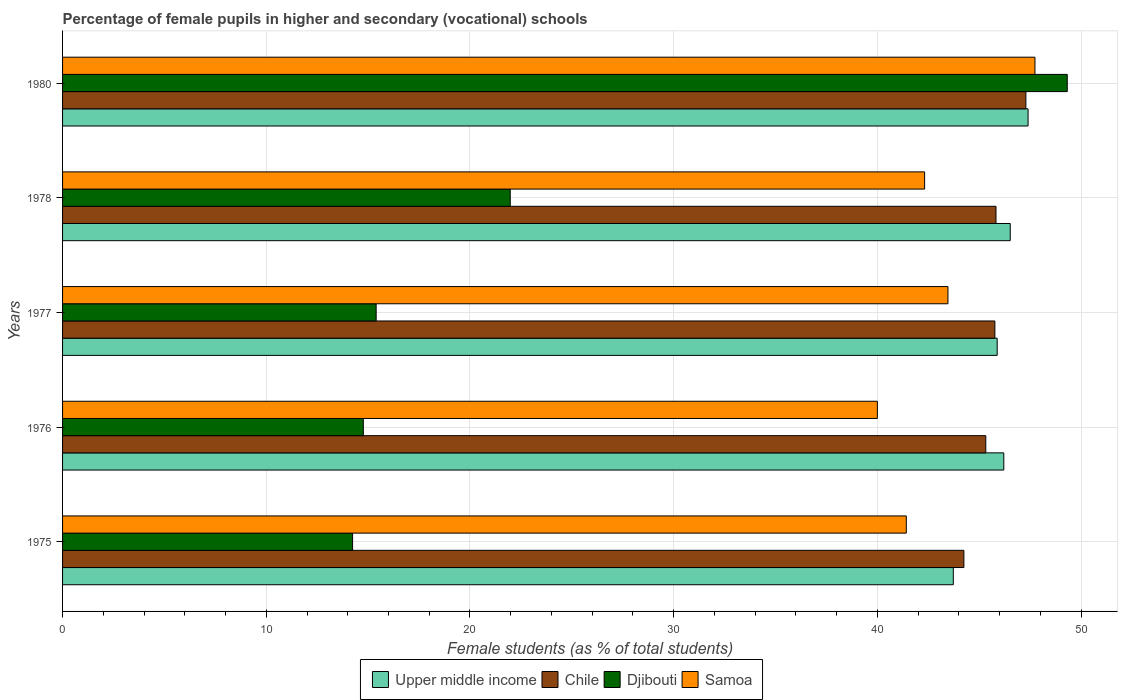How many bars are there on the 5th tick from the top?
Your answer should be very brief. 4. What is the label of the 1st group of bars from the top?
Provide a short and direct response. 1980. In how many cases, is the number of bars for a given year not equal to the number of legend labels?
Provide a succinct answer. 0. What is the percentage of female pupils in higher and secondary schools in Upper middle income in 1977?
Give a very brief answer. 45.88. Across all years, what is the maximum percentage of female pupils in higher and secondary schools in Upper middle income?
Make the answer very short. 47.4. Across all years, what is the minimum percentage of female pupils in higher and secondary schools in Samoa?
Make the answer very short. 40. In which year was the percentage of female pupils in higher and secondary schools in Samoa maximum?
Keep it short and to the point. 1980. In which year was the percentage of female pupils in higher and secondary schools in Upper middle income minimum?
Your answer should be compact. 1975. What is the total percentage of female pupils in higher and secondary schools in Upper middle income in the graph?
Keep it short and to the point. 229.74. What is the difference between the percentage of female pupils in higher and secondary schools in Upper middle income in 1976 and that in 1978?
Make the answer very short. -0.32. What is the difference between the percentage of female pupils in higher and secondary schools in Djibouti in 1980 and the percentage of female pupils in higher and secondary schools in Samoa in 1976?
Your answer should be very brief. 9.32. What is the average percentage of female pupils in higher and secondary schools in Samoa per year?
Your answer should be compact. 42.99. In the year 1980, what is the difference between the percentage of female pupils in higher and secondary schools in Samoa and percentage of female pupils in higher and secondary schools in Chile?
Provide a succinct answer. 0.45. What is the ratio of the percentage of female pupils in higher and secondary schools in Upper middle income in 1977 to that in 1978?
Your answer should be compact. 0.99. Is the difference between the percentage of female pupils in higher and secondary schools in Samoa in 1977 and 1978 greater than the difference between the percentage of female pupils in higher and secondary schools in Chile in 1977 and 1978?
Provide a short and direct response. Yes. What is the difference between the highest and the second highest percentage of female pupils in higher and secondary schools in Djibouti?
Provide a succinct answer. 27.35. What is the difference between the highest and the lowest percentage of female pupils in higher and secondary schools in Upper middle income?
Your answer should be very brief. 3.67. In how many years, is the percentage of female pupils in higher and secondary schools in Samoa greater than the average percentage of female pupils in higher and secondary schools in Samoa taken over all years?
Provide a short and direct response. 2. Is the sum of the percentage of female pupils in higher and secondary schools in Upper middle income in 1975 and 1976 greater than the maximum percentage of female pupils in higher and secondary schools in Samoa across all years?
Offer a terse response. Yes. What does the 4th bar from the top in 1975 represents?
Your answer should be compact. Upper middle income. What does the 1st bar from the bottom in 1978 represents?
Provide a short and direct response. Upper middle income. Is it the case that in every year, the sum of the percentage of female pupils in higher and secondary schools in Samoa and percentage of female pupils in higher and secondary schools in Upper middle income is greater than the percentage of female pupils in higher and secondary schools in Chile?
Provide a succinct answer. Yes. Are all the bars in the graph horizontal?
Ensure brevity in your answer.  Yes. How many years are there in the graph?
Provide a short and direct response. 5. What is the difference between two consecutive major ticks on the X-axis?
Offer a terse response. 10. Are the values on the major ticks of X-axis written in scientific E-notation?
Provide a succinct answer. No. How many legend labels are there?
Ensure brevity in your answer.  4. What is the title of the graph?
Keep it short and to the point. Percentage of female pupils in higher and secondary (vocational) schools. Does "St. Kitts and Nevis" appear as one of the legend labels in the graph?
Your response must be concise. No. What is the label or title of the X-axis?
Offer a terse response. Female students (as % of total students). What is the label or title of the Y-axis?
Offer a terse response. Years. What is the Female students (as % of total students) in Upper middle income in 1975?
Your answer should be compact. 43.73. What is the Female students (as % of total students) of Chile in 1975?
Your answer should be very brief. 44.25. What is the Female students (as % of total students) in Djibouti in 1975?
Offer a terse response. 14.24. What is the Female students (as % of total students) of Samoa in 1975?
Keep it short and to the point. 41.42. What is the Female students (as % of total students) of Upper middle income in 1976?
Offer a terse response. 46.21. What is the Female students (as % of total students) of Chile in 1976?
Your response must be concise. 45.32. What is the Female students (as % of total students) of Djibouti in 1976?
Make the answer very short. 14.77. What is the Female students (as % of total students) in Upper middle income in 1977?
Your answer should be very brief. 45.88. What is the Female students (as % of total students) in Chile in 1977?
Provide a short and direct response. 45.77. What is the Female students (as % of total students) of Djibouti in 1977?
Provide a short and direct response. 15.4. What is the Female students (as % of total students) of Samoa in 1977?
Your answer should be compact. 43.47. What is the Female students (as % of total students) of Upper middle income in 1978?
Provide a short and direct response. 46.52. What is the Female students (as % of total students) in Chile in 1978?
Make the answer very short. 45.82. What is the Female students (as % of total students) of Djibouti in 1978?
Provide a succinct answer. 21.98. What is the Female students (as % of total students) in Samoa in 1978?
Offer a terse response. 42.32. What is the Female students (as % of total students) of Upper middle income in 1980?
Keep it short and to the point. 47.4. What is the Female students (as % of total students) in Chile in 1980?
Keep it short and to the point. 47.29. What is the Female students (as % of total students) in Djibouti in 1980?
Provide a succinct answer. 49.32. What is the Female students (as % of total students) in Samoa in 1980?
Make the answer very short. 47.74. Across all years, what is the maximum Female students (as % of total students) in Upper middle income?
Provide a succinct answer. 47.4. Across all years, what is the maximum Female students (as % of total students) in Chile?
Your answer should be very brief. 47.29. Across all years, what is the maximum Female students (as % of total students) in Djibouti?
Your response must be concise. 49.32. Across all years, what is the maximum Female students (as % of total students) in Samoa?
Ensure brevity in your answer.  47.74. Across all years, what is the minimum Female students (as % of total students) in Upper middle income?
Ensure brevity in your answer.  43.73. Across all years, what is the minimum Female students (as % of total students) in Chile?
Give a very brief answer. 44.25. Across all years, what is the minimum Female students (as % of total students) in Djibouti?
Offer a very short reply. 14.24. What is the total Female students (as % of total students) of Upper middle income in the graph?
Offer a terse response. 229.74. What is the total Female students (as % of total students) in Chile in the graph?
Provide a short and direct response. 228.45. What is the total Female students (as % of total students) of Djibouti in the graph?
Your answer should be compact. 115.7. What is the total Female students (as % of total students) of Samoa in the graph?
Provide a succinct answer. 214.94. What is the difference between the Female students (as % of total students) of Upper middle income in 1975 and that in 1976?
Your response must be concise. -2.48. What is the difference between the Female students (as % of total students) of Chile in 1975 and that in 1976?
Your answer should be compact. -1.08. What is the difference between the Female students (as % of total students) in Djibouti in 1975 and that in 1976?
Your response must be concise. -0.53. What is the difference between the Female students (as % of total students) of Samoa in 1975 and that in 1976?
Provide a succinct answer. 1.42. What is the difference between the Female students (as % of total students) in Upper middle income in 1975 and that in 1977?
Provide a succinct answer. -2.15. What is the difference between the Female students (as % of total students) of Chile in 1975 and that in 1977?
Ensure brevity in your answer.  -1.52. What is the difference between the Female students (as % of total students) of Djibouti in 1975 and that in 1977?
Your answer should be very brief. -1.16. What is the difference between the Female students (as % of total students) in Samoa in 1975 and that in 1977?
Make the answer very short. -2.04. What is the difference between the Female students (as % of total students) in Upper middle income in 1975 and that in 1978?
Make the answer very short. -2.8. What is the difference between the Female students (as % of total students) of Chile in 1975 and that in 1978?
Offer a very short reply. -1.58. What is the difference between the Female students (as % of total students) of Djibouti in 1975 and that in 1978?
Offer a very short reply. -7.74. What is the difference between the Female students (as % of total students) in Samoa in 1975 and that in 1978?
Give a very brief answer. -0.9. What is the difference between the Female students (as % of total students) in Upper middle income in 1975 and that in 1980?
Your answer should be very brief. -3.67. What is the difference between the Female students (as % of total students) in Chile in 1975 and that in 1980?
Your answer should be compact. -3.04. What is the difference between the Female students (as % of total students) of Djibouti in 1975 and that in 1980?
Your response must be concise. -35.08. What is the difference between the Female students (as % of total students) of Samoa in 1975 and that in 1980?
Your answer should be very brief. -6.32. What is the difference between the Female students (as % of total students) of Upper middle income in 1976 and that in 1977?
Provide a short and direct response. 0.33. What is the difference between the Female students (as % of total students) of Chile in 1976 and that in 1977?
Your answer should be very brief. -0.45. What is the difference between the Female students (as % of total students) in Djibouti in 1976 and that in 1977?
Provide a succinct answer. -0.63. What is the difference between the Female students (as % of total students) in Samoa in 1976 and that in 1977?
Provide a short and direct response. -3.46. What is the difference between the Female students (as % of total students) in Upper middle income in 1976 and that in 1978?
Give a very brief answer. -0.32. What is the difference between the Female students (as % of total students) in Chile in 1976 and that in 1978?
Give a very brief answer. -0.5. What is the difference between the Female students (as % of total students) of Djibouti in 1976 and that in 1978?
Provide a succinct answer. -7.21. What is the difference between the Female students (as % of total students) of Samoa in 1976 and that in 1978?
Ensure brevity in your answer.  -2.32. What is the difference between the Female students (as % of total students) in Upper middle income in 1976 and that in 1980?
Your answer should be compact. -1.19. What is the difference between the Female students (as % of total students) of Chile in 1976 and that in 1980?
Ensure brevity in your answer.  -1.97. What is the difference between the Female students (as % of total students) in Djibouti in 1976 and that in 1980?
Provide a succinct answer. -34.56. What is the difference between the Female students (as % of total students) in Samoa in 1976 and that in 1980?
Your response must be concise. -7.74. What is the difference between the Female students (as % of total students) in Upper middle income in 1977 and that in 1978?
Offer a very short reply. -0.64. What is the difference between the Female students (as % of total students) of Chile in 1977 and that in 1978?
Offer a very short reply. -0.05. What is the difference between the Female students (as % of total students) of Djibouti in 1977 and that in 1978?
Offer a terse response. -6.58. What is the difference between the Female students (as % of total students) in Samoa in 1977 and that in 1978?
Ensure brevity in your answer.  1.15. What is the difference between the Female students (as % of total students) in Upper middle income in 1977 and that in 1980?
Your answer should be very brief. -1.52. What is the difference between the Female students (as % of total students) in Chile in 1977 and that in 1980?
Provide a short and direct response. -1.52. What is the difference between the Female students (as % of total students) of Djibouti in 1977 and that in 1980?
Your response must be concise. -33.93. What is the difference between the Female students (as % of total students) of Samoa in 1977 and that in 1980?
Ensure brevity in your answer.  -4.27. What is the difference between the Female students (as % of total students) of Upper middle income in 1978 and that in 1980?
Your answer should be very brief. -0.87. What is the difference between the Female students (as % of total students) of Chile in 1978 and that in 1980?
Keep it short and to the point. -1.47. What is the difference between the Female students (as % of total students) in Djibouti in 1978 and that in 1980?
Offer a very short reply. -27.35. What is the difference between the Female students (as % of total students) in Samoa in 1978 and that in 1980?
Provide a succinct answer. -5.42. What is the difference between the Female students (as % of total students) in Upper middle income in 1975 and the Female students (as % of total students) in Chile in 1976?
Give a very brief answer. -1.59. What is the difference between the Female students (as % of total students) in Upper middle income in 1975 and the Female students (as % of total students) in Djibouti in 1976?
Make the answer very short. 28.96. What is the difference between the Female students (as % of total students) in Upper middle income in 1975 and the Female students (as % of total students) in Samoa in 1976?
Provide a short and direct response. 3.73. What is the difference between the Female students (as % of total students) in Chile in 1975 and the Female students (as % of total students) in Djibouti in 1976?
Your response must be concise. 29.48. What is the difference between the Female students (as % of total students) of Chile in 1975 and the Female students (as % of total students) of Samoa in 1976?
Offer a terse response. 4.25. What is the difference between the Female students (as % of total students) in Djibouti in 1975 and the Female students (as % of total students) in Samoa in 1976?
Provide a short and direct response. -25.76. What is the difference between the Female students (as % of total students) in Upper middle income in 1975 and the Female students (as % of total students) in Chile in 1977?
Ensure brevity in your answer.  -2.04. What is the difference between the Female students (as % of total students) in Upper middle income in 1975 and the Female students (as % of total students) in Djibouti in 1977?
Provide a succinct answer. 28.33. What is the difference between the Female students (as % of total students) in Upper middle income in 1975 and the Female students (as % of total students) in Samoa in 1977?
Your answer should be compact. 0.26. What is the difference between the Female students (as % of total students) in Chile in 1975 and the Female students (as % of total students) in Djibouti in 1977?
Make the answer very short. 28.85. What is the difference between the Female students (as % of total students) in Chile in 1975 and the Female students (as % of total students) in Samoa in 1977?
Your answer should be compact. 0.78. What is the difference between the Female students (as % of total students) of Djibouti in 1975 and the Female students (as % of total students) of Samoa in 1977?
Offer a very short reply. -29.23. What is the difference between the Female students (as % of total students) of Upper middle income in 1975 and the Female students (as % of total students) of Chile in 1978?
Give a very brief answer. -2.1. What is the difference between the Female students (as % of total students) in Upper middle income in 1975 and the Female students (as % of total students) in Djibouti in 1978?
Offer a terse response. 21.75. What is the difference between the Female students (as % of total students) of Upper middle income in 1975 and the Female students (as % of total students) of Samoa in 1978?
Make the answer very short. 1.41. What is the difference between the Female students (as % of total students) in Chile in 1975 and the Female students (as % of total students) in Djibouti in 1978?
Your answer should be very brief. 22.27. What is the difference between the Female students (as % of total students) of Chile in 1975 and the Female students (as % of total students) of Samoa in 1978?
Make the answer very short. 1.93. What is the difference between the Female students (as % of total students) in Djibouti in 1975 and the Female students (as % of total students) in Samoa in 1978?
Provide a short and direct response. -28.08. What is the difference between the Female students (as % of total students) of Upper middle income in 1975 and the Female students (as % of total students) of Chile in 1980?
Your answer should be very brief. -3.56. What is the difference between the Female students (as % of total students) of Upper middle income in 1975 and the Female students (as % of total students) of Djibouti in 1980?
Ensure brevity in your answer.  -5.59. What is the difference between the Female students (as % of total students) of Upper middle income in 1975 and the Female students (as % of total students) of Samoa in 1980?
Make the answer very short. -4.01. What is the difference between the Female students (as % of total students) of Chile in 1975 and the Female students (as % of total students) of Djibouti in 1980?
Give a very brief answer. -5.07. What is the difference between the Female students (as % of total students) in Chile in 1975 and the Female students (as % of total students) in Samoa in 1980?
Provide a succinct answer. -3.49. What is the difference between the Female students (as % of total students) of Djibouti in 1975 and the Female students (as % of total students) of Samoa in 1980?
Make the answer very short. -33.5. What is the difference between the Female students (as % of total students) in Upper middle income in 1976 and the Female students (as % of total students) in Chile in 1977?
Your answer should be compact. 0.44. What is the difference between the Female students (as % of total students) of Upper middle income in 1976 and the Female students (as % of total students) of Djibouti in 1977?
Your answer should be very brief. 30.81. What is the difference between the Female students (as % of total students) of Upper middle income in 1976 and the Female students (as % of total students) of Samoa in 1977?
Provide a succinct answer. 2.74. What is the difference between the Female students (as % of total students) of Chile in 1976 and the Female students (as % of total students) of Djibouti in 1977?
Your answer should be compact. 29.93. What is the difference between the Female students (as % of total students) in Chile in 1976 and the Female students (as % of total students) in Samoa in 1977?
Ensure brevity in your answer.  1.86. What is the difference between the Female students (as % of total students) in Djibouti in 1976 and the Female students (as % of total students) in Samoa in 1977?
Your answer should be compact. -28.7. What is the difference between the Female students (as % of total students) of Upper middle income in 1976 and the Female students (as % of total students) of Chile in 1978?
Your answer should be very brief. 0.38. What is the difference between the Female students (as % of total students) of Upper middle income in 1976 and the Female students (as % of total students) of Djibouti in 1978?
Provide a succinct answer. 24.23. What is the difference between the Female students (as % of total students) in Upper middle income in 1976 and the Female students (as % of total students) in Samoa in 1978?
Your answer should be very brief. 3.89. What is the difference between the Female students (as % of total students) of Chile in 1976 and the Female students (as % of total students) of Djibouti in 1978?
Your answer should be compact. 23.35. What is the difference between the Female students (as % of total students) in Chile in 1976 and the Female students (as % of total students) in Samoa in 1978?
Provide a short and direct response. 3. What is the difference between the Female students (as % of total students) of Djibouti in 1976 and the Female students (as % of total students) of Samoa in 1978?
Your response must be concise. -27.55. What is the difference between the Female students (as % of total students) of Upper middle income in 1976 and the Female students (as % of total students) of Chile in 1980?
Give a very brief answer. -1.08. What is the difference between the Female students (as % of total students) in Upper middle income in 1976 and the Female students (as % of total students) in Djibouti in 1980?
Provide a succinct answer. -3.11. What is the difference between the Female students (as % of total students) of Upper middle income in 1976 and the Female students (as % of total students) of Samoa in 1980?
Keep it short and to the point. -1.53. What is the difference between the Female students (as % of total students) of Chile in 1976 and the Female students (as % of total students) of Djibouti in 1980?
Make the answer very short. -4. What is the difference between the Female students (as % of total students) in Chile in 1976 and the Female students (as % of total students) in Samoa in 1980?
Offer a very short reply. -2.41. What is the difference between the Female students (as % of total students) in Djibouti in 1976 and the Female students (as % of total students) in Samoa in 1980?
Keep it short and to the point. -32.97. What is the difference between the Female students (as % of total students) of Upper middle income in 1977 and the Female students (as % of total students) of Chile in 1978?
Offer a terse response. 0.06. What is the difference between the Female students (as % of total students) of Upper middle income in 1977 and the Female students (as % of total students) of Djibouti in 1978?
Make the answer very short. 23.91. What is the difference between the Female students (as % of total students) in Upper middle income in 1977 and the Female students (as % of total students) in Samoa in 1978?
Your answer should be very brief. 3.56. What is the difference between the Female students (as % of total students) of Chile in 1977 and the Female students (as % of total students) of Djibouti in 1978?
Keep it short and to the point. 23.79. What is the difference between the Female students (as % of total students) in Chile in 1977 and the Female students (as % of total students) in Samoa in 1978?
Provide a succinct answer. 3.45. What is the difference between the Female students (as % of total students) in Djibouti in 1977 and the Female students (as % of total students) in Samoa in 1978?
Offer a very short reply. -26.92. What is the difference between the Female students (as % of total students) of Upper middle income in 1977 and the Female students (as % of total students) of Chile in 1980?
Provide a short and direct response. -1.41. What is the difference between the Female students (as % of total students) of Upper middle income in 1977 and the Female students (as % of total students) of Djibouti in 1980?
Keep it short and to the point. -3.44. What is the difference between the Female students (as % of total students) of Upper middle income in 1977 and the Female students (as % of total students) of Samoa in 1980?
Your answer should be very brief. -1.85. What is the difference between the Female students (as % of total students) in Chile in 1977 and the Female students (as % of total students) in Djibouti in 1980?
Your answer should be very brief. -3.55. What is the difference between the Female students (as % of total students) of Chile in 1977 and the Female students (as % of total students) of Samoa in 1980?
Give a very brief answer. -1.97. What is the difference between the Female students (as % of total students) in Djibouti in 1977 and the Female students (as % of total students) in Samoa in 1980?
Your answer should be compact. -32.34. What is the difference between the Female students (as % of total students) of Upper middle income in 1978 and the Female students (as % of total students) of Chile in 1980?
Ensure brevity in your answer.  -0.77. What is the difference between the Female students (as % of total students) of Upper middle income in 1978 and the Female students (as % of total students) of Djibouti in 1980?
Your answer should be very brief. -2.8. What is the difference between the Female students (as % of total students) of Upper middle income in 1978 and the Female students (as % of total students) of Samoa in 1980?
Give a very brief answer. -1.21. What is the difference between the Female students (as % of total students) of Chile in 1978 and the Female students (as % of total students) of Djibouti in 1980?
Offer a very short reply. -3.5. What is the difference between the Female students (as % of total students) in Chile in 1978 and the Female students (as % of total students) in Samoa in 1980?
Provide a succinct answer. -1.91. What is the difference between the Female students (as % of total students) of Djibouti in 1978 and the Female students (as % of total students) of Samoa in 1980?
Provide a succinct answer. -25.76. What is the average Female students (as % of total students) of Upper middle income per year?
Give a very brief answer. 45.95. What is the average Female students (as % of total students) in Chile per year?
Ensure brevity in your answer.  45.69. What is the average Female students (as % of total students) in Djibouti per year?
Your answer should be compact. 23.14. What is the average Female students (as % of total students) in Samoa per year?
Your answer should be compact. 42.99. In the year 1975, what is the difference between the Female students (as % of total students) of Upper middle income and Female students (as % of total students) of Chile?
Make the answer very short. -0.52. In the year 1975, what is the difference between the Female students (as % of total students) in Upper middle income and Female students (as % of total students) in Djibouti?
Provide a short and direct response. 29.49. In the year 1975, what is the difference between the Female students (as % of total students) of Upper middle income and Female students (as % of total students) of Samoa?
Keep it short and to the point. 2.31. In the year 1975, what is the difference between the Female students (as % of total students) in Chile and Female students (as % of total students) in Djibouti?
Make the answer very short. 30.01. In the year 1975, what is the difference between the Female students (as % of total students) in Chile and Female students (as % of total students) in Samoa?
Offer a terse response. 2.83. In the year 1975, what is the difference between the Female students (as % of total students) in Djibouti and Female students (as % of total students) in Samoa?
Provide a succinct answer. -27.18. In the year 1976, what is the difference between the Female students (as % of total students) of Upper middle income and Female students (as % of total students) of Chile?
Keep it short and to the point. 0.89. In the year 1976, what is the difference between the Female students (as % of total students) in Upper middle income and Female students (as % of total students) in Djibouti?
Offer a terse response. 31.44. In the year 1976, what is the difference between the Female students (as % of total students) in Upper middle income and Female students (as % of total students) in Samoa?
Your response must be concise. 6.21. In the year 1976, what is the difference between the Female students (as % of total students) of Chile and Female students (as % of total students) of Djibouti?
Offer a terse response. 30.56. In the year 1976, what is the difference between the Female students (as % of total students) of Chile and Female students (as % of total students) of Samoa?
Offer a very short reply. 5.32. In the year 1976, what is the difference between the Female students (as % of total students) in Djibouti and Female students (as % of total students) in Samoa?
Give a very brief answer. -25.23. In the year 1977, what is the difference between the Female students (as % of total students) of Upper middle income and Female students (as % of total students) of Chile?
Offer a very short reply. 0.11. In the year 1977, what is the difference between the Female students (as % of total students) in Upper middle income and Female students (as % of total students) in Djibouti?
Provide a short and direct response. 30.49. In the year 1977, what is the difference between the Female students (as % of total students) of Upper middle income and Female students (as % of total students) of Samoa?
Provide a succinct answer. 2.42. In the year 1977, what is the difference between the Female students (as % of total students) of Chile and Female students (as % of total students) of Djibouti?
Your answer should be very brief. 30.37. In the year 1977, what is the difference between the Female students (as % of total students) of Chile and Female students (as % of total students) of Samoa?
Offer a very short reply. 2.3. In the year 1977, what is the difference between the Female students (as % of total students) in Djibouti and Female students (as % of total students) in Samoa?
Your response must be concise. -28.07. In the year 1978, what is the difference between the Female students (as % of total students) of Upper middle income and Female students (as % of total students) of Chile?
Make the answer very short. 0.7. In the year 1978, what is the difference between the Female students (as % of total students) in Upper middle income and Female students (as % of total students) in Djibouti?
Your answer should be compact. 24.55. In the year 1978, what is the difference between the Female students (as % of total students) in Upper middle income and Female students (as % of total students) in Samoa?
Your answer should be very brief. 4.2. In the year 1978, what is the difference between the Female students (as % of total students) in Chile and Female students (as % of total students) in Djibouti?
Offer a terse response. 23.85. In the year 1978, what is the difference between the Female students (as % of total students) of Chile and Female students (as % of total students) of Samoa?
Your answer should be compact. 3.5. In the year 1978, what is the difference between the Female students (as % of total students) in Djibouti and Female students (as % of total students) in Samoa?
Provide a short and direct response. -20.34. In the year 1980, what is the difference between the Female students (as % of total students) in Upper middle income and Female students (as % of total students) in Chile?
Ensure brevity in your answer.  0.11. In the year 1980, what is the difference between the Female students (as % of total students) in Upper middle income and Female students (as % of total students) in Djibouti?
Ensure brevity in your answer.  -1.92. In the year 1980, what is the difference between the Female students (as % of total students) of Upper middle income and Female students (as % of total students) of Samoa?
Your answer should be very brief. -0.34. In the year 1980, what is the difference between the Female students (as % of total students) in Chile and Female students (as % of total students) in Djibouti?
Your answer should be very brief. -2.03. In the year 1980, what is the difference between the Female students (as % of total students) of Chile and Female students (as % of total students) of Samoa?
Ensure brevity in your answer.  -0.45. In the year 1980, what is the difference between the Female students (as % of total students) in Djibouti and Female students (as % of total students) in Samoa?
Your answer should be compact. 1.59. What is the ratio of the Female students (as % of total students) in Upper middle income in 1975 to that in 1976?
Offer a very short reply. 0.95. What is the ratio of the Female students (as % of total students) of Chile in 1975 to that in 1976?
Ensure brevity in your answer.  0.98. What is the ratio of the Female students (as % of total students) in Samoa in 1975 to that in 1976?
Offer a very short reply. 1.04. What is the ratio of the Female students (as % of total students) of Upper middle income in 1975 to that in 1977?
Provide a succinct answer. 0.95. What is the ratio of the Female students (as % of total students) of Chile in 1975 to that in 1977?
Offer a very short reply. 0.97. What is the ratio of the Female students (as % of total students) of Djibouti in 1975 to that in 1977?
Make the answer very short. 0.92. What is the ratio of the Female students (as % of total students) in Samoa in 1975 to that in 1977?
Give a very brief answer. 0.95. What is the ratio of the Female students (as % of total students) in Upper middle income in 1975 to that in 1978?
Your answer should be very brief. 0.94. What is the ratio of the Female students (as % of total students) in Chile in 1975 to that in 1978?
Provide a succinct answer. 0.97. What is the ratio of the Female students (as % of total students) of Djibouti in 1975 to that in 1978?
Give a very brief answer. 0.65. What is the ratio of the Female students (as % of total students) in Samoa in 1975 to that in 1978?
Provide a short and direct response. 0.98. What is the ratio of the Female students (as % of total students) in Upper middle income in 1975 to that in 1980?
Keep it short and to the point. 0.92. What is the ratio of the Female students (as % of total students) of Chile in 1975 to that in 1980?
Make the answer very short. 0.94. What is the ratio of the Female students (as % of total students) of Djibouti in 1975 to that in 1980?
Your answer should be very brief. 0.29. What is the ratio of the Female students (as % of total students) of Samoa in 1975 to that in 1980?
Make the answer very short. 0.87. What is the ratio of the Female students (as % of total students) of Upper middle income in 1976 to that in 1977?
Provide a succinct answer. 1.01. What is the ratio of the Female students (as % of total students) in Chile in 1976 to that in 1977?
Give a very brief answer. 0.99. What is the ratio of the Female students (as % of total students) in Djibouti in 1976 to that in 1977?
Keep it short and to the point. 0.96. What is the ratio of the Female students (as % of total students) in Samoa in 1976 to that in 1977?
Provide a succinct answer. 0.92. What is the ratio of the Female students (as % of total students) of Chile in 1976 to that in 1978?
Offer a terse response. 0.99. What is the ratio of the Female students (as % of total students) in Djibouti in 1976 to that in 1978?
Ensure brevity in your answer.  0.67. What is the ratio of the Female students (as % of total students) in Samoa in 1976 to that in 1978?
Make the answer very short. 0.95. What is the ratio of the Female students (as % of total students) of Upper middle income in 1976 to that in 1980?
Provide a short and direct response. 0.97. What is the ratio of the Female students (as % of total students) in Chile in 1976 to that in 1980?
Ensure brevity in your answer.  0.96. What is the ratio of the Female students (as % of total students) of Djibouti in 1976 to that in 1980?
Offer a terse response. 0.3. What is the ratio of the Female students (as % of total students) in Samoa in 1976 to that in 1980?
Offer a terse response. 0.84. What is the ratio of the Female students (as % of total students) of Upper middle income in 1977 to that in 1978?
Ensure brevity in your answer.  0.99. What is the ratio of the Female students (as % of total students) of Djibouti in 1977 to that in 1978?
Your answer should be very brief. 0.7. What is the ratio of the Female students (as % of total students) of Samoa in 1977 to that in 1978?
Offer a terse response. 1.03. What is the ratio of the Female students (as % of total students) in Chile in 1977 to that in 1980?
Provide a succinct answer. 0.97. What is the ratio of the Female students (as % of total students) in Djibouti in 1977 to that in 1980?
Your answer should be compact. 0.31. What is the ratio of the Female students (as % of total students) in Samoa in 1977 to that in 1980?
Offer a very short reply. 0.91. What is the ratio of the Female students (as % of total students) in Upper middle income in 1978 to that in 1980?
Provide a succinct answer. 0.98. What is the ratio of the Female students (as % of total students) in Chile in 1978 to that in 1980?
Keep it short and to the point. 0.97. What is the ratio of the Female students (as % of total students) of Djibouti in 1978 to that in 1980?
Give a very brief answer. 0.45. What is the ratio of the Female students (as % of total students) in Samoa in 1978 to that in 1980?
Give a very brief answer. 0.89. What is the difference between the highest and the second highest Female students (as % of total students) in Upper middle income?
Make the answer very short. 0.87. What is the difference between the highest and the second highest Female students (as % of total students) in Chile?
Provide a short and direct response. 1.47. What is the difference between the highest and the second highest Female students (as % of total students) in Djibouti?
Offer a very short reply. 27.35. What is the difference between the highest and the second highest Female students (as % of total students) of Samoa?
Give a very brief answer. 4.27. What is the difference between the highest and the lowest Female students (as % of total students) of Upper middle income?
Offer a very short reply. 3.67. What is the difference between the highest and the lowest Female students (as % of total students) of Chile?
Provide a succinct answer. 3.04. What is the difference between the highest and the lowest Female students (as % of total students) of Djibouti?
Provide a short and direct response. 35.08. What is the difference between the highest and the lowest Female students (as % of total students) in Samoa?
Offer a terse response. 7.74. 